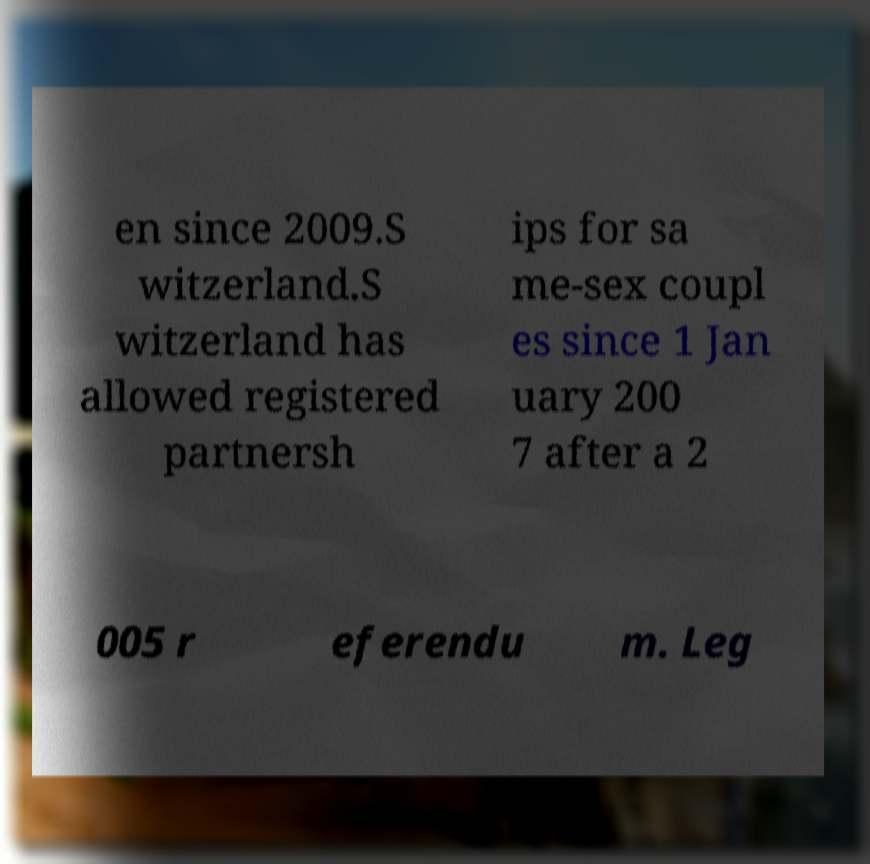Please identify and transcribe the text found in this image. en since 2009.S witzerland.S witzerland has allowed registered partnersh ips for sa me-sex coupl es since 1 Jan uary 200 7 after a 2 005 r eferendu m. Leg 